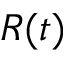Convert formula to latex. <formula><loc_0><loc_0><loc_500><loc_500>R ( t )</formula> 